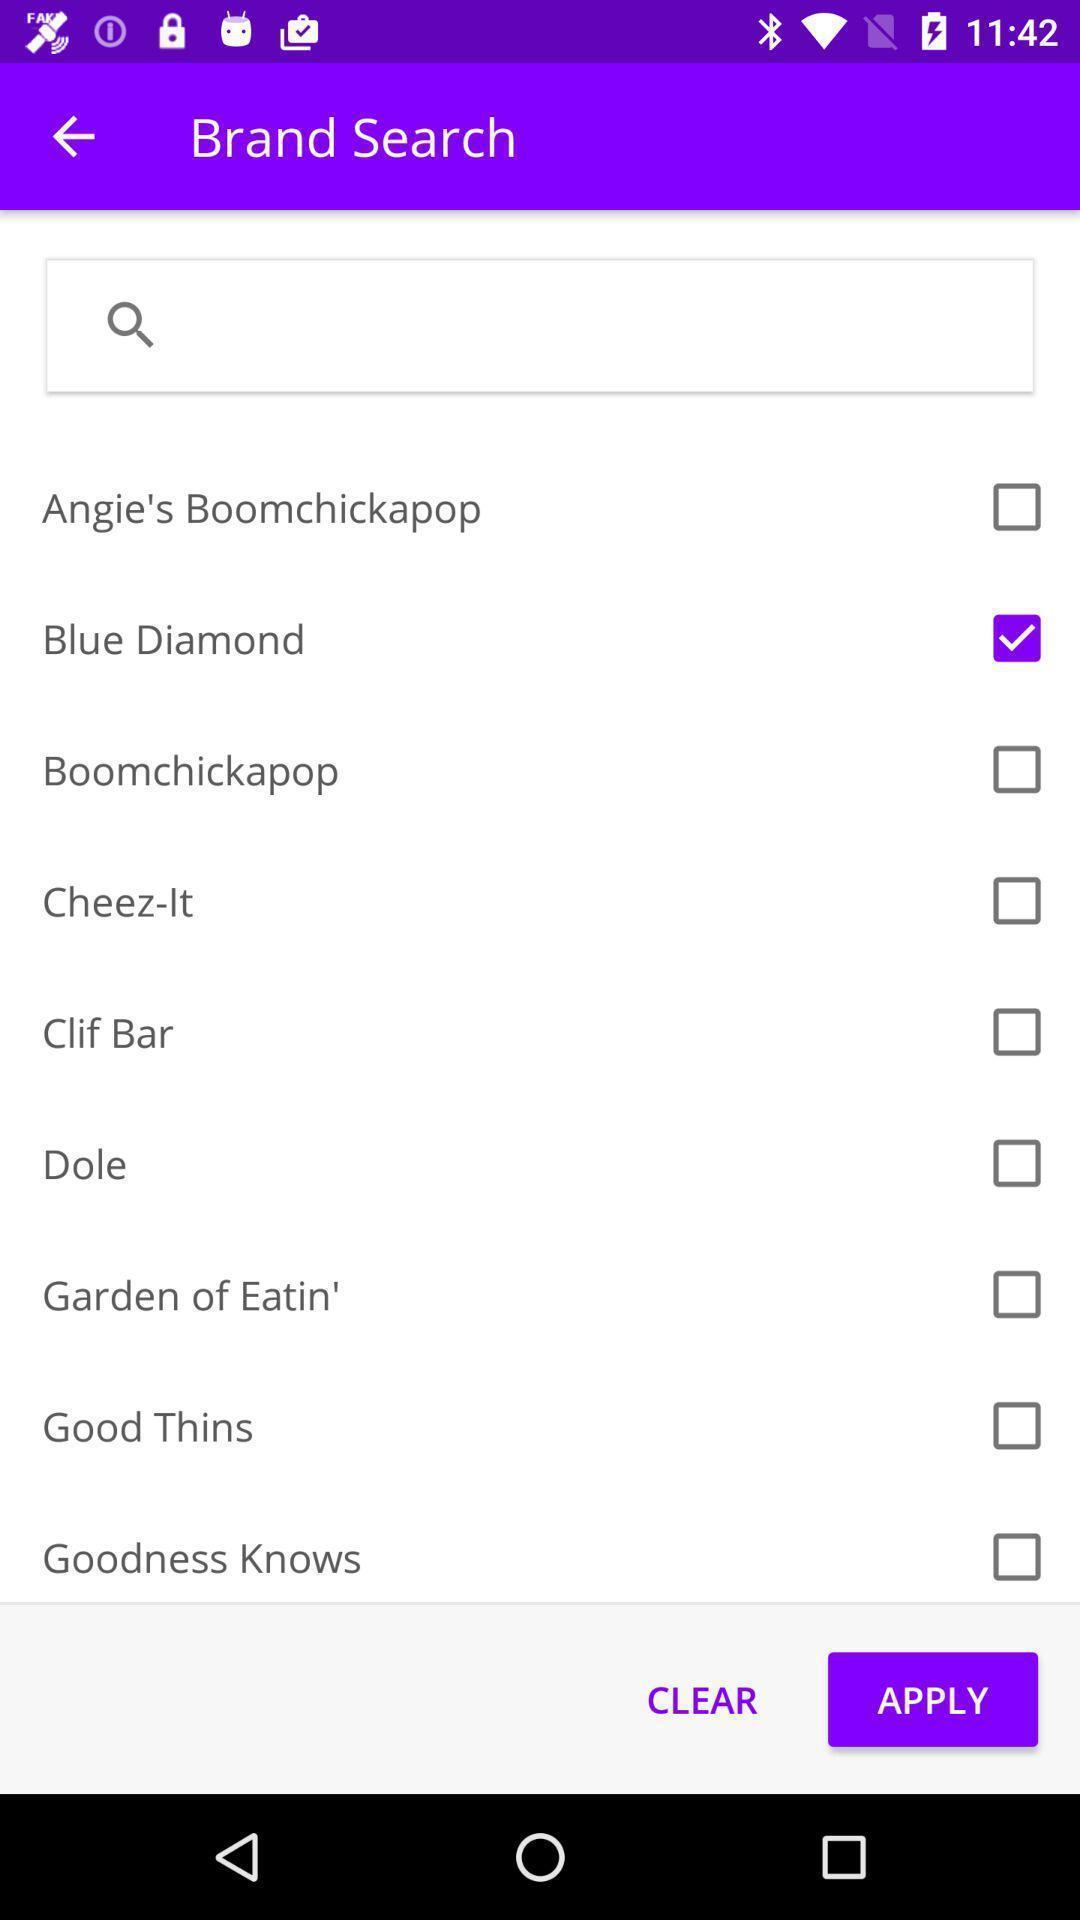Describe the content in this image. Search bar to search for brand in app. 